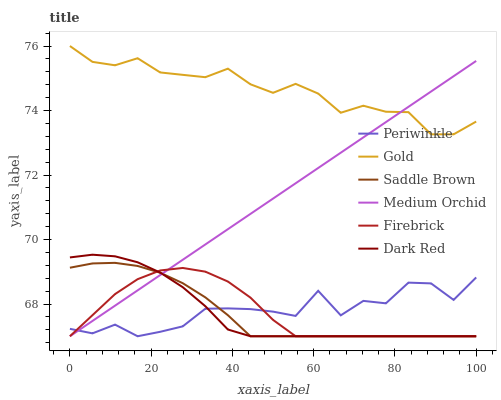Does Dark Red have the minimum area under the curve?
Answer yes or no. Yes. Does Gold have the maximum area under the curve?
Answer yes or no. Yes. Does Firebrick have the minimum area under the curve?
Answer yes or no. No. Does Firebrick have the maximum area under the curve?
Answer yes or no. No. Is Medium Orchid the smoothest?
Answer yes or no. Yes. Is Periwinkle the roughest?
Answer yes or no. Yes. Is Dark Red the smoothest?
Answer yes or no. No. Is Dark Red the roughest?
Answer yes or no. No. Does Dark Red have the lowest value?
Answer yes or no. Yes. Does Gold have the highest value?
Answer yes or no. Yes. Does Dark Red have the highest value?
Answer yes or no. No. Is Firebrick less than Gold?
Answer yes or no. Yes. Is Gold greater than Firebrick?
Answer yes or no. Yes. Does Dark Red intersect Medium Orchid?
Answer yes or no. Yes. Is Dark Red less than Medium Orchid?
Answer yes or no. No. Is Dark Red greater than Medium Orchid?
Answer yes or no. No. Does Firebrick intersect Gold?
Answer yes or no. No. 